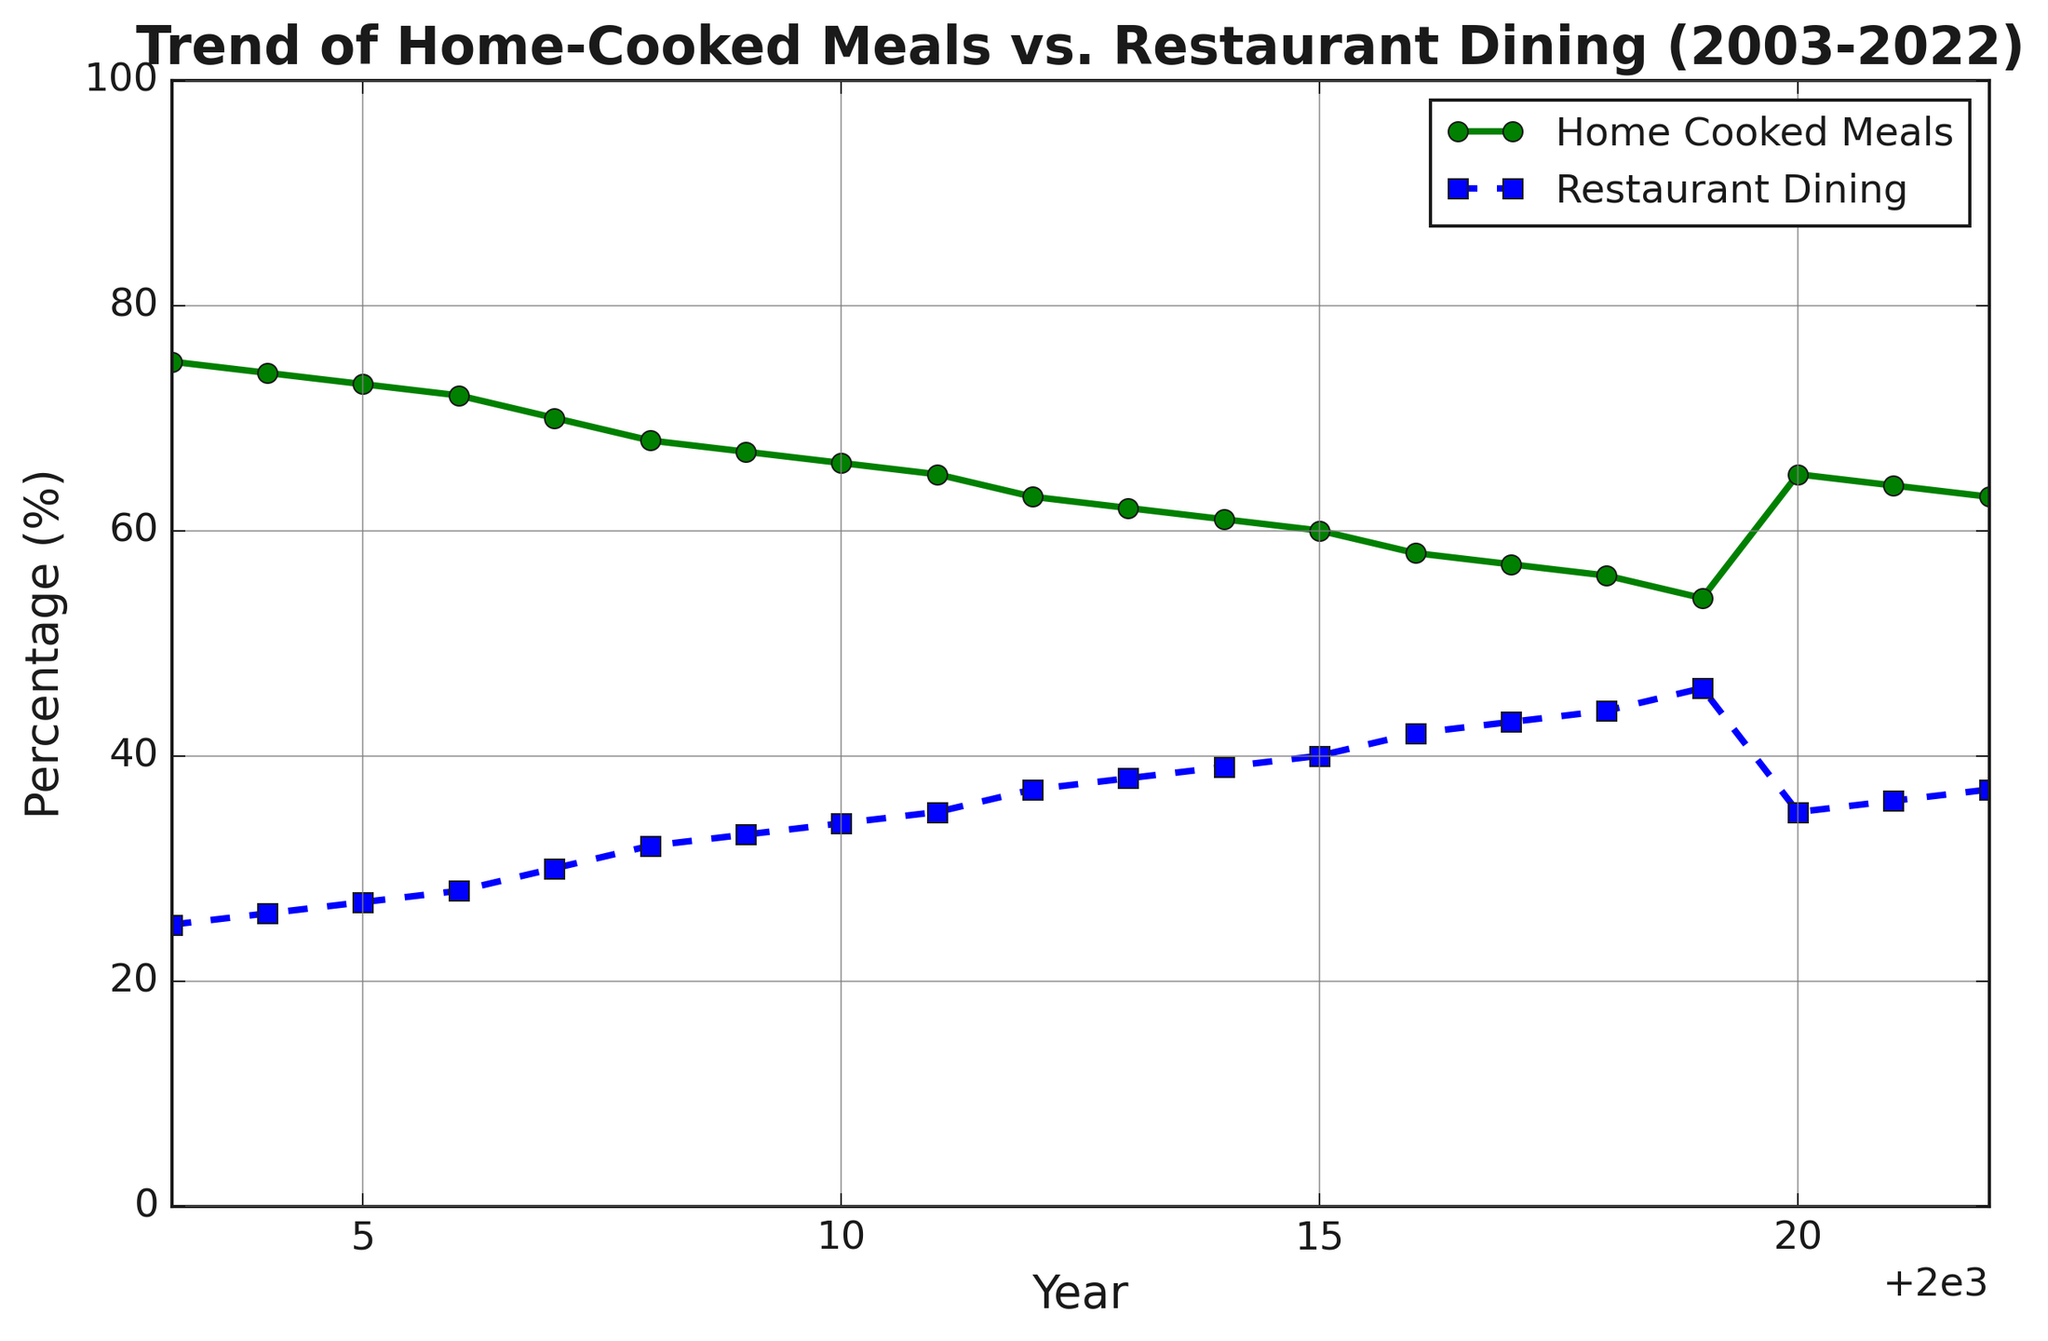What is the trend of home-cooked meals percentage over the last 20 years? The plot shows a general downward trend in the percentage of home-cooked meals from 75% in 2003 to 54% in 2019, with a slight increase to 65% in 2020 before gradually falling to 63% by 2022.
Answer: Downward trend with slight increase in 2020 How does the percentage of restaurant dining in 2022 compare with its value in 2003? In 2003, restaurant dining was at 25%. By 2022, it increased to 37%. Thus, the percentage rose by 12 percentage points over this period.
Answer: Increased by 12 percentage points Which year experienced the most significant increase in home-cooked meals? The most significant increase can be observed in 2020, where the percentage of home-cooked meals jumped from 54% in 2019 to 65% in 2020, an increase of 11 percentage points.
Answer: 2020 What is the difference between the highest and lowest values of home-cooked meals over the years? The highest value of home-cooked meals is 75% in 2003, and the lowest is 54% in 2019. The difference between these values is 75% - 54% = 21 percentage points.
Answer: 21 percentage points Between 2005 and 2010, what is the average percentage of restaurant dining? Adding the percentages of restaurant dining from 2005 to 2010: 27%, 28%, 30%, 32%, 33%, 34%, and dividing by 6 gives (27 + 28 + 30 + 32 + 33 + 34) / 6 = 30.67%.
Answer: 30.67% In which years do home-cooked meals and restaurant dining percentages sum up to 100%? Checking the data year by year, they sum to 100% for every year from 2003 to 2022 as combining values like 75% + 25% (for 2003), 74% + 26% (for 2004), and so on always equal to 100%.
Answer: Every year from 2003 to 2022 By how many percentage points did home-cooked meals decrease from 2003 to 2019? In 2003, home-cooked meals were at 75%, and in 2019, they were at 54%. The decrease is 75% - 54% = 21 percentage points.
Answer: 21 percentage points What can you infer about the relationship between the trends of home-cooked meals and restaurant dining over time? As the percentage of home-cooked meals decreased, the percentage of restaurant dining increased, showing an inverse relationship. When home-cooked meals rose in 2020, restaurant dining fell, also demonstrating this inverse relationship.
Answer: Inverse relationship What could be a possible explanation for the spike in home-cooked meals in 2020? One possible explanation is the impact of the COVID-19 pandemic, which led to lockdowns and restricted dining out, resulting in more people cooking at home.
Answer: COVID-19 pandemic impact 